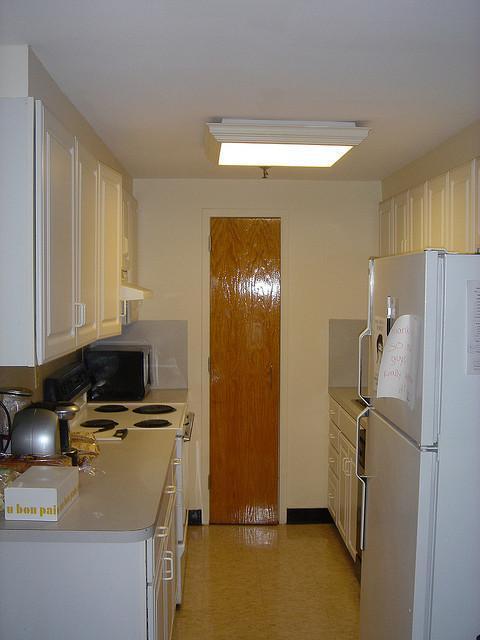How many lights are there?
Give a very brief answer. 1. How many ovens are in this kitchen?
Give a very brief answer. 1. How many refrigerators are in the photo?
Give a very brief answer. 1. How many ovens are there?
Give a very brief answer. 1. 